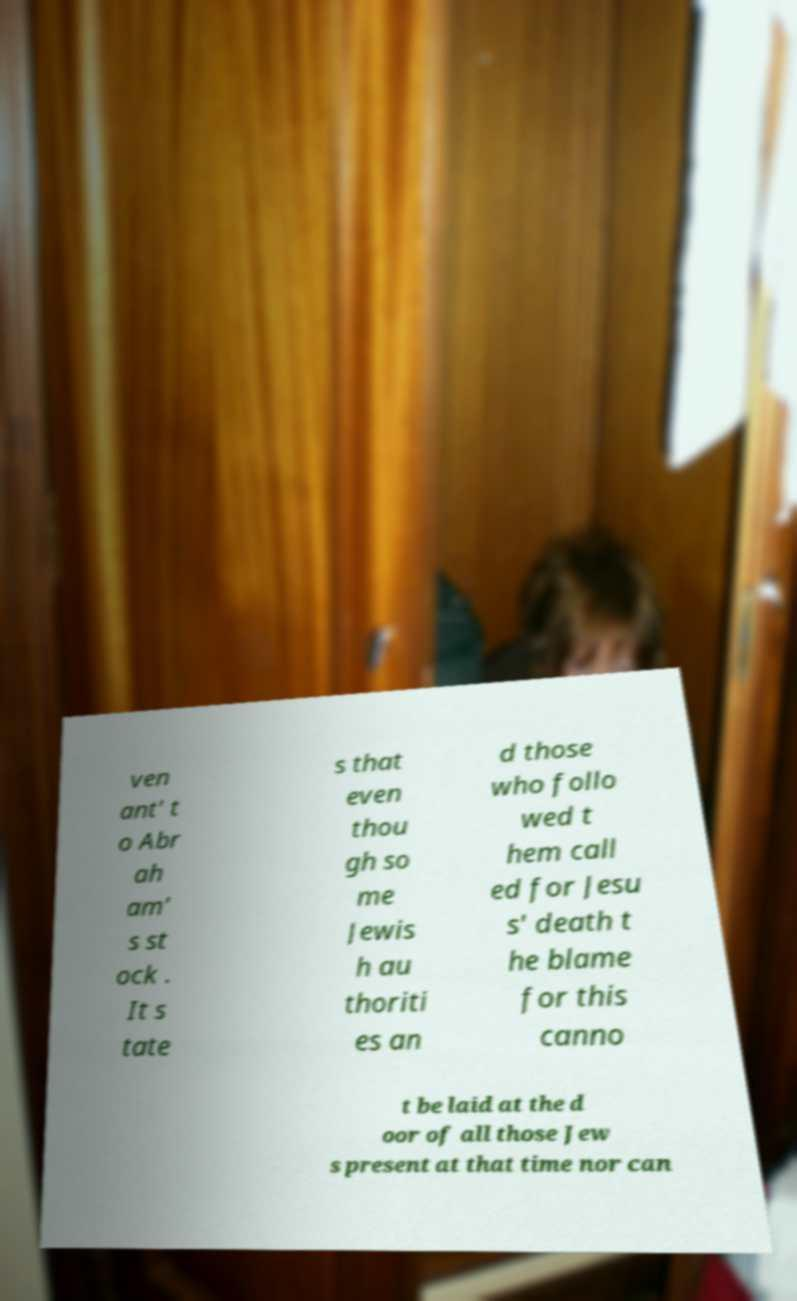For documentation purposes, I need the text within this image transcribed. Could you provide that? ven ant' t o Abr ah am' s st ock . It s tate s that even thou gh so me Jewis h au thoriti es an d those who follo wed t hem call ed for Jesu s' death t he blame for this canno t be laid at the d oor of all those Jew s present at that time nor can 